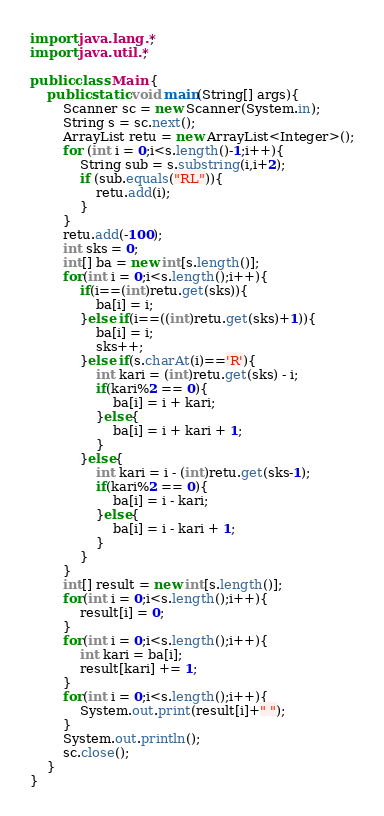<code> <loc_0><loc_0><loc_500><loc_500><_Java_>import java.lang.*;
import java.util.*;

public class Main {
    public static void main(String[] args){
        Scanner sc = new Scanner(System.in);
        String s = sc.next();
        ArrayList retu = new ArrayList<Integer>();
        for (int i = 0;i<s.length()-1;i++){
            String sub = s.substring(i,i+2);
            if (sub.equals("RL")){
                retu.add(i);
            }
        }
        retu.add(-100);
        int sks = 0;
        int[] ba = new int[s.length()];
        for(int i = 0;i<s.length();i++){
            if(i==(int)retu.get(sks)){
                ba[i] = i;
            }else if(i==((int)retu.get(sks)+1)){
                ba[i] = i;
                sks++;
            }else if(s.charAt(i)=='R'){
                int kari = (int)retu.get(sks) - i;
                if(kari%2 == 0){
                    ba[i] = i + kari;
                }else{
                    ba[i] = i + kari + 1;
                }
            }else{
                int kari = i - (int)retu.get(sks-1);
                if(kari%2 == 0){
                    ba[i] = i - kari;
                }else{
                    ba[i] = i - kari + 1;
                }
            }
        }
        int[] result = new int[s.length()];
        for(int i = 0;i<s.length();i++){
            result[i] = 0;
        }
        for(int i = 0;i<s.length();i++){
            int kari = ba[i];
            result[kari] += 1;
        }
        for(int i = 0;i<s.length();i++){
            System.out.print(result[i]+" ");
        }
        System.out.println();
        sc.close();
    }
}</code> 